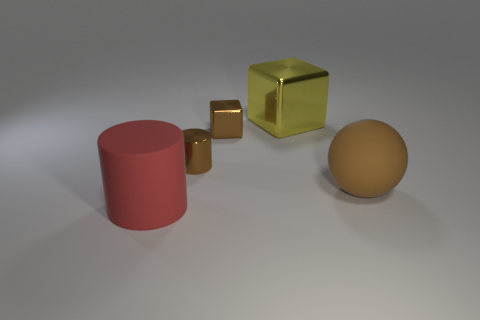Add 1 small cylinders. How many objects exist? 6 Subtract all spheres. How many objects are left? 4 Subtract 0 blue cylinders. How many objects are left? 5 Subtract all big brown rubber balls. Subtract all tiny brown objects. How many objects are left? 2 Add 3 large yellow objects. How many large yellow objects are left? 4 Add 1 small gray shiny objects. How many small gray shiny objects exist? 1 